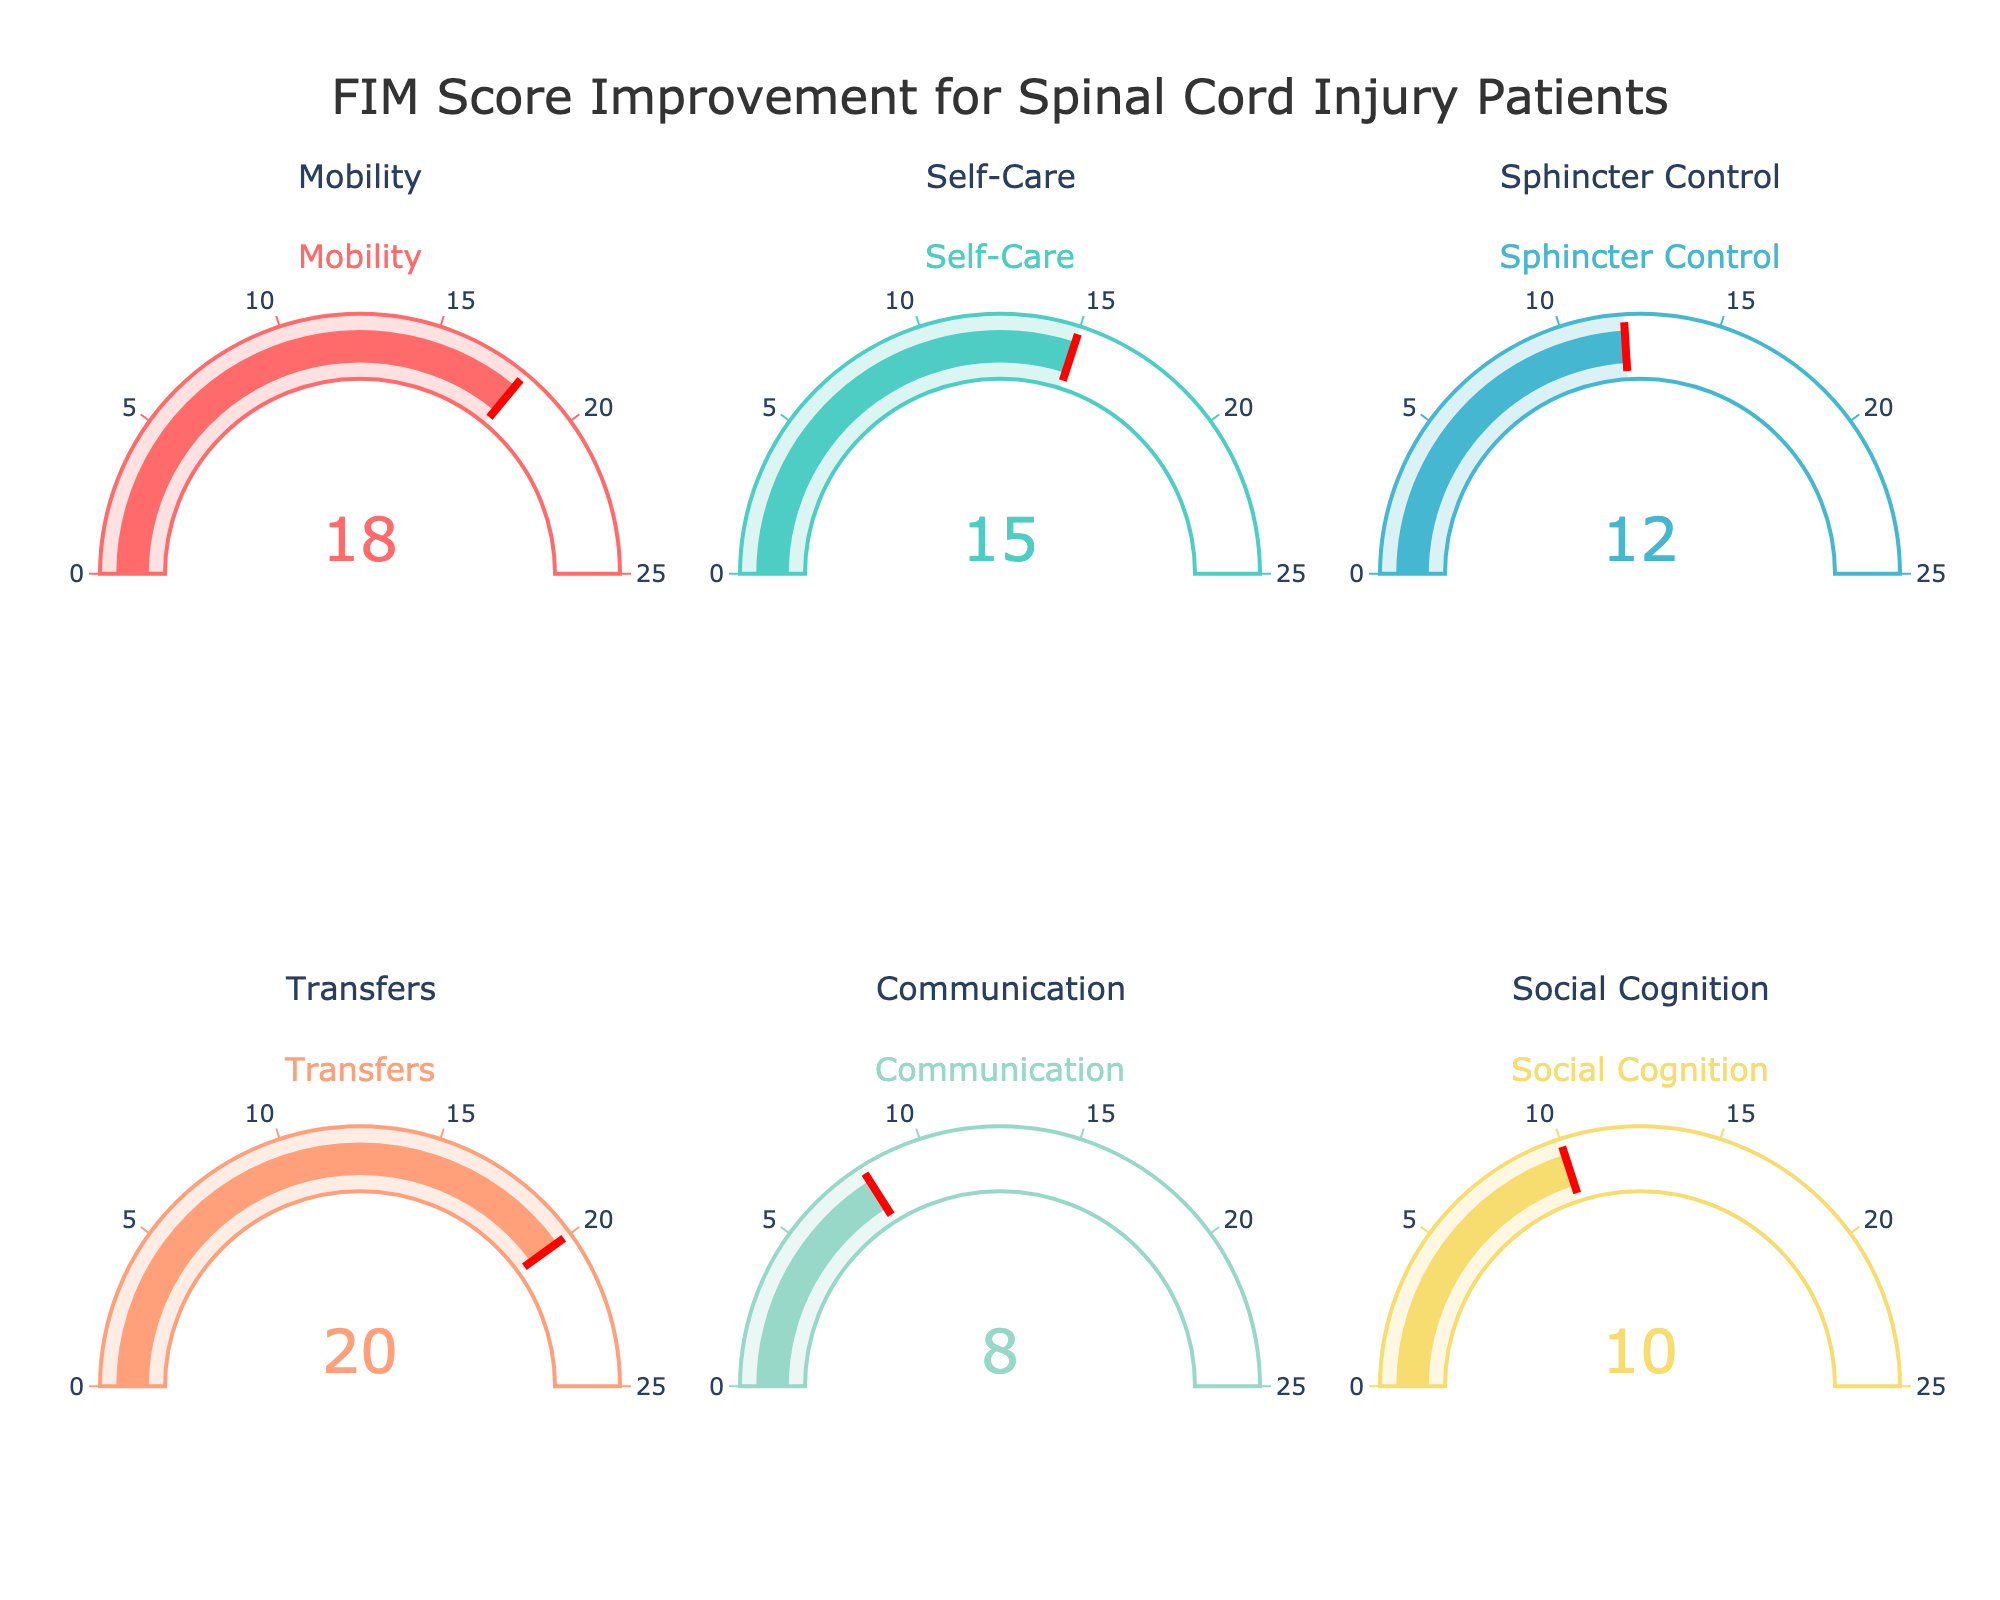What's the title of the figure? The title is typically found at the top of the figure. In this case, it reads "FIM Score Improvement for Spinal Cord Injury Patients".
Answer: FIM Score Improvement for Spinal Cord Injury Patients What is the average improvement score across all categories? Add all the FIM score improvements and divide by the number of categories: (18 + 15 + 12 + 20 + 8 + 10) / 6. This results in an average of 83 / 6 = 13.83.
Answer: 13.83 Which category has the highest improvement in FIM score? Look at all gauges and identify the one with the highest number. The 'Transfers' category has the highest score of 20.
Answer: Transfers Which two categories have the lowest FIM score improvements? Compare all the gauges and find the two categories with the smallest numbers. 'Communication' and 'Social Cognition' show the lowest scores with improvements of 8 and 10 respectively.
Answer: Communication and Social Cognition What is the difference in FIM score improvement between 'Mobility' and 'Communication'? Subtract the FIM score of 'Communication' from 'Mobility': 18 - 8 = 10.
Answer: 10 How many categories have a FIM score improvement greater than 15? Check each gauge and count the categories with scores above 15. These are 'Mobility' (18) and 'Transfers' (20).
Answer: 2 What color is associated with the 'Self-Care' category? Look at the color of the gauge for the 'Self-Care' category. It is turquoise-like, specifically '#4ECDC4'.
Answer: Turquoise (#4ECDC4) What is the sum of improvement scores in 'Sphincter Control' and 'Social Cognition'? Add the FIM score improvement in 'Sphincter Control' (12) and 'Social Cognition' (10): 12 + 10 = 22.
Answer: 22 Which category has a FIM score improvement closest to the average? Calculate the differences between the average improvement (13.83) and each category's improvement. 'Self-Care' (15) has the smallest difference (15 - 13.83 = 1.17).
Answer: Self-Care 